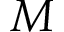<formula> <loc_0><loc_0><loc_500><loc_500>M</formula> 